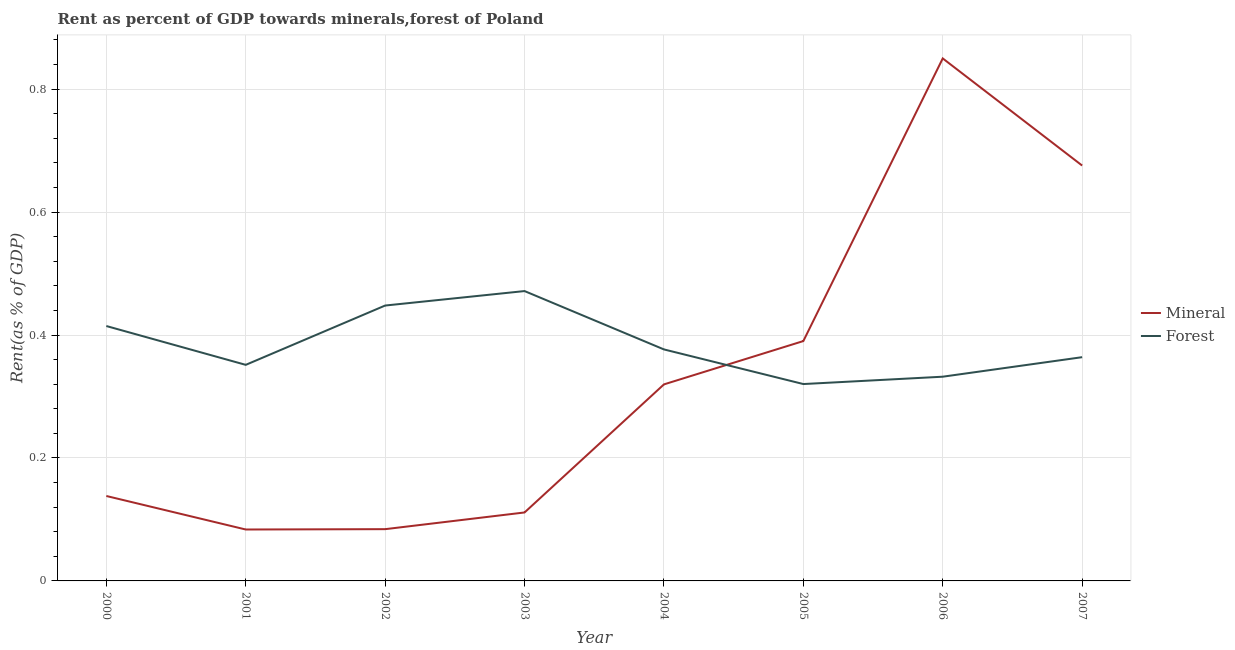Does the line corresponding to forest rent intersect with the line corresponding to mineral rent?
Ensure brevity in your answer.  Yes. Is the number of lines equal to the number of legend labels?
Provide a short and direct response. Yes. What is the forest rent in 2003?
Offer a terse response. 0.47. Across all years, what is the maximum forest rent?
Give a very brief answer. 0.47. Across all years, what is the minimum forest rent?
Provide a short and direct response. 0.32. In which year was the mineral rent minimum?
Give a very brief answer. 2001. What is the total forest rent in the graph?
Offer a very short reply. 3.08. What is the difference between the forest rent in 2002 and that in 2005?
Offer a very short reply. 0.13. What is the difference between the mineral rent in 2004 and the forest rent in 2003?
Make the answer very short. -0.15. What is the average forest rent per year?
Your answer should be compact. 0.38. In the year 2007, what is the difference between the forest rent and mineral rent?
Offer a very short reply. -0.31. In how many years, is the mineral rent greater than 0.48000000000000004 %?
Give a very brief answer. 2. What is the ratio of the mineral rent in 2002 to that in 2003?
Keep it short and to the point. 0.76. Is the mineral rent in 2000 less than that in 2007?
Provide a short and direct response. Yes. What is the difference between the highest and the second highest mineral rent?
Your answer should be very brief. 0.17. What is the difference between the highest and the lowest mineral rent?
Give a very brief answer. 0.77. In how many years, is the mineral rent greater than the average mineral rent taken over all years?
Your answer should be compact. 3. Is the sum of the forest rent in 2002 and 2007 greater than the maximum mineral rent across all years?
Give a very brief answer. No. Does the mineral rent monotonically increase over the years?
Your answer should be compact. No. Is the forest rent strictly greater than the mineral rent over the years?
Provide a succinct answer. No. Is the forest rent strictly less than the mineral rent over the years?
Offer a very short reply. No. How many years are there in the graph?
Your answer should be very brief. 8. What is the difference between two consecutive major ticks on the Y-axis?
Your response must be concise. 0.2. Does the graph contain grids?
Keep it short and to the point. Yes. What is the title of the graph?
Ensure brevity in your answer.  Rent as percent of GDP towards minerals,forest of Poland. Does "Start a business" appear as one of the legend labels in the graph?
Keep it short and to the point. No. What is the label or title of the Y-axis?
Provide a short and direct response. Rent(as % of GDP). What is the Rent(as % of GDP) of Mineral in 2000?
Provide a short and direct response. 0.14. What is the Rent(as % of GDP) in Forest in 2000?
Make the answer very short. 0.41. What is the Rent(as % of GDP) in Mineral in 2001?
Your answer should be compact. 0.08. What is the Rent(as % of GDP) of Forest in 2001?
Keep it short and to the point. 0.35. What is the Rent(as % of GDP) of Mineral in 2002?
Your answer should be very brief. 0.08. What is the Rent(as % of GDP) in Forest in 2002?
Your response must be concise. 0.45. What is the Rent(as % of GDP) in Mineral in 2003?
Offer a terse response. 0.11. What is the Rent(as % of GDP) in Forest in 2003?
Offer a very short reply. 0.47. What is the Rent(as % of GDP) of Mineral in 2004?
Provide a succinct answer. 0.32. What is the Rent(as % of GDP) in Forest in 2004?
Ensure brevity in your answer.  0.38. What is the Rent(as % of GDP) in Mineral in 2005?
Make the answer very short. 0.39. What is the Rent(as % of GDP) of Forest in 2005?
Ensure brevity in your answer.  0.32. What is the Rent(as % of GDP) in Mineral in 2006?
Ensure brevity in your answer.  0.85. What is the Rent(as % of GDP) of Forest in 2006?
Your answer should be compact. 0.33. What is the Rent(as % of GDP) in Mineral in 2007?
Your response must be concise. 0.68. What is the Rent(as % of GDP) in Forest in 2007?
Provide a succinct answer. 0.36. Across all years, what is the maximum Rent(as % of GDP) of Mineral?
Provide a short and direct response. 0.85. Across all years, what is the maximum Rent(as % of GDP) of Forest?
Make the answer very short. 0.47. Across all years, what is the minimum Rent(as % of GDP) of Mineral?
Your answer should be very brief. 0.08. Across all years, what is the minimum Rent(as % of GDP) of Forest?
Provide a succinct answer. 0.32. What is the total Rent(as % of GDP) of Mineral in the graph?
Your answer should be very brief. 2.65. What is the total Rent(as % of GDP) of Forest in the graph?
Provide a short and direct response. 3.08. What is the difference between the Rent(as % of GDP) of Mineral in 2000 and that in 2001?
Offer a terse response. 0.05. What is the difference between the Rent(as % of GDP) in Forest in 2000 and that in 2001?
Keep it short and to the point. 0.06. What is the difference between the Rent(as % of GDP) in Mineral in 2000 and that in 2002?
Your response must be concise. 0.05. What is the difference between the Rent(as % of GDP) of Forest in 2000 and that in 2002?
Ensure brevity in your answer.  -0.03. What is the difference between the Rent(as % of GDP) in Mineral in 2000 and that in 2003?
Provide a succinct answer. 0.03. What is the difference between the Rent(as % of GDP) in Forest in 2000 and that in 2003?
Give a very brief answer. -0.06. What is the difference between the Rent(as % of GDP) of Mineral in 2000 and that in 2004?
Keep it short and to the point. -0.18. What is the difference between the Rent(as % of GDP) in Forest in 2000 and that in 2004?
Your answer should be very brief. 0.04. What is the difference between the Rent(as % of GDP) in Mineral in 2000 and that in 2005?
Provide a short and direct response. -0.25. What is the difference between the Rent(as % of GDP) of Forest in 2000 and that in 2005?
Keep it short and to the point. 0.09. What is the difference between the Rent(as % of GDP) in Mineral in 2000 and that in 2006?
Offer a terse response. -0.71. What is the difference between the Rent(as % of GDP) of Forest in 2000 and that in 2006?
Ensure brevity in your answer.  0.08. What is the difference between the Rent(as % of GDP) in Mineral in 2000 and that in 2007?
Your response must be concise. -0.54. What is the difference between the Rent(as % of GDP) in Forest in 2000 and that in 2007?
Offer a very short reply. 0.05. What is the difference between the Rent(as % of GDP) in Mineral in 2001 and that in 2002?
Ensure brevity in your answer.  -0. What is the difference between the Rent(as % of GDP) of Forest in 2001 and that in 2002?
Offer a terse response. -0.1. What is the difference between the Rent(as % of GDP) of Mineral in 2001 and that in 2003?
Ensure brevity in your answer.  -0.03. What is the difference between the Rent(as % of GDP) in Forest in 2001 and that in 2003?
Provide a succinct answer. -0.12. What is the difference between the Rent(as % of GDP) in Mineral in 2001 and that in 2004?
Give a very brief answer. -0.24. What is the difference between the Rent(as % of GDP) in Forest in 2001 and that in 2004?
Your answer should be very brief. -0.03. What is the difference between the Rent(as % of GDP) of Mineral in 2001 and that in 2005?
Your response must be concise. -0.31. What is the difference between the Rent(as % of GDP) of Forest in 2001 and that in 2005?
Offer a very short reply. 0.03. What is the difference between the Rent(as % of GDP) of Mineral in 2001 and that in 2006?
Ensure brevity in your answer.  -0.77. What is the difference between the Rent(as % of GDP) of Forest in 2001 and that in 2006?
Your response must be concise. 0.02. What is the difference between the Rent(as % of GDP) of Mineral in 2001 and that in 2007?
Make the answer very short. -0.59. What is the difference between the Rent(as % of GDP) of Forest in 2001 and that in 2007?
Your answer should be compact. -0.01. What is the difference between the Rent(as % of GDP) in Mineral in 2002 and that in 2003?
Offer a terse response. -0.03. What is the difference between the Rent(as % of GDP) of Forest in 2002 and that in 2003?
Your answer should be compact. -0.02. What is the difference between the Rent(as % of GDP) in Mineral in 2002 and that in 2004?
Your answer should be very brief. -0.24. What is the difference between the Rent(as % of GDP) of Forest in 2002 and that in 2004?
Your response must be concise. 0.07. What is the difference between the Rent(as % of GDP) in Mineral in 2002 and that in 2005?
Give a very brief answer. -0.31. What is the difference between the Rent(as % of GDP) in Forest in 2002 and that in 2005?
Provide a short and direct response. 0.13. What is the difference between the Rent(as % of GDP) in Mineral in 2002 and that in 2006?
Your answer should be compact. -0.77. What is the difference between the Rent(as % of GDP) of Forest in 2002 and that in 2006?
Keep it short and to the point. 0.12. What is the difference between the Rent(as % of GDP) of Mineral in 2002 and that in 2007?
Offer a very short reply. -0.59. What is the difference between the Rent(as % of GDP) in Forest in 2002 and that in 2007?
Your answer should be compact. 0.08. What is the difference between the Rent(as % of GDP) in Mineral in 2003 and that in 2004?
Ensure brevity in your answer.  -0.21. What is the difference between the Rent(as % of GDP) in Forest in 2003 and that in 2004?
Make the answer very short. 0.09. What is the difference between the Rent(as % of GDP) in Mineral in 2003 and that in 2005?
Your answer should be very brief. -0.28. What is the difference between the Rent(as % of GDP) in Forest in 2003 and that in 2005?
Your answer should be compact. 0.15. What is the difference between the Rent(as % of GDP) of Mineral in 2003 and that in 2006?
Your response must be concise. -0.74. What is the difference between the Rent(as % of GDP) in Forest in 2003 and that in 2006?
Keep it short and to the point. 0.14. What is the difference between the Rent(as % of GDP) of Mineral in 2003 and that in 2007?
Provide a succinct answer. -0.56. What is the difference between the Rent(as % of GDP) in Forest in 2003 and that in 2007?
Your response must be concise. 0.11. What is the difference between the Rent(as % of GDP) of Mineral in 2004 and that in 2005?
Ensure brevity in your answer.  -0.07. What is the difference between the Rent(as % of GDP) of Forest in 2004 and that in 2005?
Provide a succinct answer. 0.06. What is the difference between the Rent(as % of GDP) in Mineral in 2004 and that in 2006?
Your response must be concise. -0.53. What is the difference between the Rent(as % of GDP) of Forest in 2004 and that in 2006?
Keep it short and to the point. 0.04. What is the difference between the Rent(as % of GDP) of Mineral in 2004 and that in 2007?
Ensure brevity in your answer.  -0.36. What is the difference between the Rent(as % of GDP) of Forest in 2004 and that in 2007?
Offer a terse response. 0.01. What is the difference between the Rent(as % of GDP) of Mineral in 2005 and that in 2006?
Your answer should be very brief. -0.46. What is the difference between the Rent(as % of GDP) in Forest in 2005 and that in 2006?
Your answer should be compact. -0.01. What is the difference between the Rent(as % of GDP) of Mineral in 2005 and that in 2007?
Your answer should be compact. -0.29. What is the difference between the Rent(as % of GDP) of Forest in 2005 and that in 2007?
Give a very brief answer. -0.04. What is the difference between the Rent(as % of GDP) in Mineral in 2006 and that in 2007?
Make the answer very short. 0.17. What is the difference between the Rent(as % of GDP) of Forest in 2006 and that in 2007?
Ensure brevity in your answer.  -0.03. What is the difference between the Rent(as % of GDP) of Mineral in 2000 and the Rent(as % of GDP) of Forest in 2001?
Keep it short and to the point. -0.21. What is the difference between the Rent(as % of GDP) of Mineral in 2000 and the Rent(as % of GDP) of Forest in 2002?
Your response must be concise. -0.31. What is the difference between the Rent(as % of GDP) in Mineral in 2000 and the Rent(as % of GDP) in Forest in 2003?
Offer a very short reply. -0.33. What is the difference between the Rent(as % of GDP) of Mineral in 2000 and the Rent(as % of GDP) of Forest in 2004?
Offer a terse response. -0.24. What is the difference between the Rent(as % of GDP) of Mineral in 2000 and the Rent(as % of GDP) of Forest in 2005?
Provide a short and direct response. -0.18. What is the difference between the Rent(as % of GDP) of Mineral in 2000 and the Rent(as % of GDP) of Forest in 2006?
Your response must be concise. -0.19. What is the difference between the Rent(as % of GDP) in Mineral in 2000 and the Rent(as % of GDP) in Forest in 2007?
Offer a very short reply. -0.23. What is the difference between the Rent(as % of GDP) in Mineral in 2001 and the Rent(as % of GDP) in Forest in 2002?
Offer a terse response. -0.36. What is the difference between the Rent(as % of GDP) of Mineral in 2001 and the Rent(as % of GDP) of Forest in 2003?
Provide a succinct answer. -0.39. What is the difference between the Rent(as % of GDP) of Mineral in 2001 and the Rent(as % of GDP) of Forest in 2004?
Your response must be concise. -0.29. What is the difference between the Rent(as % of GDP) in Mineral in 2001 and the Rent(as % of GDP) in Forest in 2005?
Provide a short and direct response. -0.24. What is the difference between the Rent(as % of GDP) in Mineral in 2001 and the Rent(as % of GDP) in Forest in 2006?
Provide a short and direct response. -0.25. What is the difference between the Rent(as % of GDP) of Mineral in 2001 and the Rent(as % of GDP) of Forest in 2007?
Give a very brief answer. -0.28. What is the difference between the Rent(as % of GDP) in Mineral in 2002 and the Rent(as % of GDP) in Forest in 2003?
Your response must be concise. -0.39. What is the difference between the Rent(as % of GDP) of Mineral in 2002 and the Rent(as % of GDP) of Forest in 2004?
Give a very brief answer. -0.29. What is the difference between the Rent(as % of GDP) in Mineral in 2002 and the Rent(as % of GDP) in Forest in 2005?
Provide a short and direct response. -0.24. What is the difference between the Rent(as % of GDP) of Mineral in 2002 and the Rent(as % of GDP) of Forest in 2006?
Ensure brevity in your answer.  -0.25. What is the difference between the Rent(as % of GDP) of Mineral in 2002 and the Rent(as % of GDP) of Forest in 2007?
Make the answer very short. -0.28. What is the difference between the Rent(as % of GDP) in Mineral in 2003 and the Rent(as % of GDP) in Forest in 2004?
Make the answer very short. -0.27. What is the difference between the Rent(as % of GDP) in Mineral in 2003 and the Rent(as % of GDP) in Forest in 2005?
Make the answer very short. -0.21. What is the difference between the Rent(as % of GDP) of Mineral in 2003 and the Rent(as % of GDP) of Forest in 2006?
Keep it short and to the point. -0.22. What is the difference between the Rent(as % of GDP) of Mineral in 2003 and the Rent(as % of GDP) of Forest in 2007?
Ensure brevity in your answer.  -0.25. What is the difference between the Rent(as % of GDP) of Mineral in 2004 and the Rent(as % of GDP) of Forest in 2005?
Offer a very short reply. -0. What is the difference between the Rent(as % of GDP) in Mineral in 2004 and the Rent(as % of GDP) in Forest in 2006?
Give a very brief answer. -0.01. What is the difference between the Rent(as % of GDP) in Mineral in 2004 and the Rent(as % of GDP) in Forest in 2007?
Your answer should be compact. -0.04. What is the difference between the Rent(as % of GDP) in Mineral in 2005 and the Rent(as % of GDP) in Forest in 2006?
Provide a short and direct response. 0.06. What is the difference between the Rent(as % of GDP) of Mineral in 2005 and the Rent(as % of GDP) of Forest in 2007?
Ensure brevity in your answer.  0.03. What is the difference between the Rent(as % of GDP) of Mineral in 2006 and the Rent(as % of GDP) of Forest in 2007?
Give a very brief answer. 0.49. What is the average Rent(as % of GDP) in Mineral per year?
Your answer should be very brief. 0.33. What is the average Rent(as % of GDP) of Forest per year?
Give a very brief answer. 0.38. In the year 2000, what is the difference between the Rent(as % of GDP) in Mineral and Rent(as % of GDP) in Forest?
Make the answer very short. -0.28. In the year 2001, what is the difference between the Rent(as % of GDP) in Mineral and Rent(as % of GDP) in Forest?
Offer a very short reply. -0.27. In the year 2002, what is the difference between the Rent(as % of GDP) in Mineral and Rent(as % of GDP) in Forest?
Make the answer very short. -0.36. In the year 2003, what is the difference between the Rent(as % of GDP) of Mineral and Rent(as % of GDP) of Forest?
Make the answer very short. -0.36. In the year 2004, what is the difference between the Rent(as % of GDP) of Mineral and Rent(as % of GDP) of Forest?
Your response must be concise. -0.06. In the year 2005, what is the difference between the Rent(as % of GDP) in Mineral and Rent(as % of GDP) in Forest?
Keep it short and to the point. 0.07. In the year 2006, what is the difference between the Rent(as % of GDP) in Mineral and Rent(as % of GDP) in Forest?
Ensure brevity in your answer.  0.52. In the year 2007, what is the difference between the Rent(as % of GDP) of Mineral and Rent(as % of GDP) of Forest?
Ensure brevity in your answer.  0.31. What is the ratio of the Rent(as % of GDP) of Mineral in 2000 to that in 2001?
Provide a succinct answer. 1.65. What is the ratio of the Rent(as % of GDP) of Forest in 2000 to that in 2001?
Offer a very short reply. 1.18. What is the ratio of the Rent(as % of GDP) in Mineral in 2000 to that in 2002?
Your answer should be compact. 1.64. What is the ratio of the Rent(as % of GDP) in Forest in 2000 to that in 2002?
Your answer should be very brief. 0.93. What is the ratio of the Rent(as % of GDP) in Mineral in 2000 to that in 2003?
Keep it short and to the point. 1.24. What is the ratio of the Rent(as % of GDP) in Forest in 2000 to that in 2003?
Make the answer very short. 0.88. What is the ratio of the Rent(as % of GDP) in Mineral in 2000 to that in 2004?
Offer a very short reply. 0.43. What is the ratio of the Rent(as % of GDP) in Forest in 2000 to that in 2004?
Your answer should be compact. 1.1. What is the ratio of the Rent(as % of GDP) in Mineral in 2000 to that in 2005?
Give a very brief answer. 0.35. What is the ratio of the Rent(as % of GDP) in Forest in 2000 to that in 2005?
Give a very brief answer. 1.29. What is the ratio of the Rent(as % of GDP) in Mineral in 2000 to that in 2006?
Your answer should be very brief. 0.16. What is the ratio of the Rent(as % of GDP) of Forest in 2000 to that in 2006?
Keep it short and to the point. 1.25. What is the ratio of the Rent(as % of GDP) of Mineral in 2000 to that in 2007?
Give a very brief answer. 0.2. What is the ratio of the Rent(as % of GDP) in Forest in 2000 to that in 2007?
Ensure brevity in your answer.  1.14. What is the ratio of the Rent(as % of GDP) in Mineral in 2001 to that in 2002?
Your answer should be compact. 0.99. What is the ratio of the Rent(as % of GDP) of Forest in 2001 to that in 2002?
Your answer should be compact. 0.78. What is the ratio of the Rent(as % of GDP) in Mineral in 2001 to that in 2003?
Your answer should be very brief. 0.75. What is the ratio of the Rent(as % of GDP) in Forest in 2001 to that in 2003?
Offer a very short reply. 0.75. What is the ratio of the Rent(as % of GDP) of Mineral in 2001 to that in 2004?
Provide a short and direct response. 0.26. What is the ratio of the Rent(as % of GDP) in Mineral in 2001 to that in 2005?
Offer a terse response. 0.21. What is the ratio of the Rent(as % of GDP) in Forest in 2001 to that in 2005?
Your response must be concise. 1.1. What is the ratio of the Rent(as % of GDP) of Mineral in 2001 to that in 2006?
Make the answer very short. 0.1. What is the ratio of the Rent(as % of GDP) in Forest in 2001 to that in 2006?
Make the answer very short. 1.06. What is the ratio of the Rent(as % of GDP) in Mineral in 2001 to that in 2007?
Provide a short and direct response. 0.12. What is the ratio of the Rent(as % of GDP) in Forest in 2001 to that in 2007?
Offer a very short reply. 0.97. What is the ratio of the Rent(as % of GDP) of Mineral in 2002 to that in 2003?
Keep it short and to the point. 0.76. What is the ratio of the Rent(as % of GDP) in Forest in 2002 to that in 2003?
Give a very brief answer. 0.95. What is the ratio of the Rent(as % of GDP) of Mineral in 2002 to that in 2004?
Keep it short and to the point. 0.26. What is the ratio of the Rent(as % of GDP) of Forest in 2002 to that in 2004?
Keep it short and to the point. 1.19. What is the ratio of the Rent(as % of GDP) of Mineral in 2002 to that in 2005?
Your answer should be very brief. 0.22. What is the ratio of the Rent(as % of GDP) of Forest in 2002 to that in 2005?
Give a very brief answer. 1.4. What is the ratio of the Rent(as % of GDP) of Mineral in 2002 to that in 2006?
Your response must be concise. 0.1. What is the ratio of the Rent(as % of GDP) of Forest in 2002 to that in 2006?
Keep it short and to the point. 1.35. What is the ratio of the Rent(as % of GDP) in Mineral in 2002 to that in 2007?
Your answer should be very brief. 0.12. What is the ratio of the Rent(as % of GDP) of Forest in 2002 to that in 2007?
Provide a succinct answer. 1.23. What is the ratio of the Rent(as % of GDP) in Mineral in 2003 to that in 2004?
Your response must be concise. 0.35. What is the ratio of the Rent(as % of GDP) of Forest in 2003 to that in 2004?
Ensure brevity in your answer.  1.25. What is the ratio of the Rent(as % of GDP) of Mineral in 2003 to that in 2005?
Your answer should be very brief. 0.29. What is the ratio of the Rent(as % of GDP) in Forest in 2003 to that in 2005?
Your response must be concise. 1.47. What is the ratio of the Rent(as % of GDP) in Mineral in 2003 to that in 2006?
Your answer should be very brief. 0.13. What is the ratio of the Rent(as % of GDP) in Forest in 2003 to that in 2006?
Your answer should be compact. 1.42. What is the ratio of the Rent(as % of GDP) in Mineral in 2003 to that in 2007?
Provide a short and direct response. 0.16. What is the ratio of the Rent(as % of GDP) in Forest in 2003 to that in 2007?
Give a very brief answer. 1.3. What is the ratio of the Rent(as % of GDP) in Mineral in 2004 to that in 2005?
Offer a very short reply. 0.82. What is the ratio of the Rent(as % of GDP) in Forest in 2004 to that in 2005?
Provide a short and direct response. 1.18. What is the ratio of the Rent(as % of GDP) of Mineral in 2004 to that in 2006?
Offer a terse response. 0.38. What is the ratio of the Rent(as % of GDP) of Forest in 2004 to that in 2006?
Your answer should be compact. 1.13. What is the ratio of the Rent(as % of GDP) of Mineral in 2004 to that in 2007?
Offer a very short reply. 0.47. What is the ratio of the Rent(as % of GDP) of Forest in 2004 to that in 2007?
Offer a terse response. 1.03. What is the ratio of the Rent(as % of GDP) of Mineral in 2005 to that in 2006?
Keep it short and to the point. 0.46. What is the ratio of the Rent(as % of GDP) in Mineral in 2005 to that in 2007?
Ensure brevity in your answer.  0.58. What is the ratio of the Rent(as % of GDP) in Forest in 2005 to that in 2007?
Offer a very short reply. 0.88. What is the ratio of the Rent(as % of GDP) of Mineral in 2006 to that in 2007?
Offer a terse response. 1.26. What is the ratio of the Rent(as % of GDP) of Forest in 2006 to that in 2007?
Your answer should be compact. 0.91. What is the difference between the highest and the second highest Rent(as % of GDP) in Mineral?
Ensure brevity in your answer.  0.17. What is the difference between the highest and the second highest Rent(as % of GDP) of Forest?
Make the answer very short. 0.02. What is the difference between the highest and the lowest Rent(as % of GDP) in Mineral?
Give a very brief answer. 0.77. What is the difference between the highest and the lowest Rent(as % of GDP) in Forest?
Your response must be concise. 0.15. 